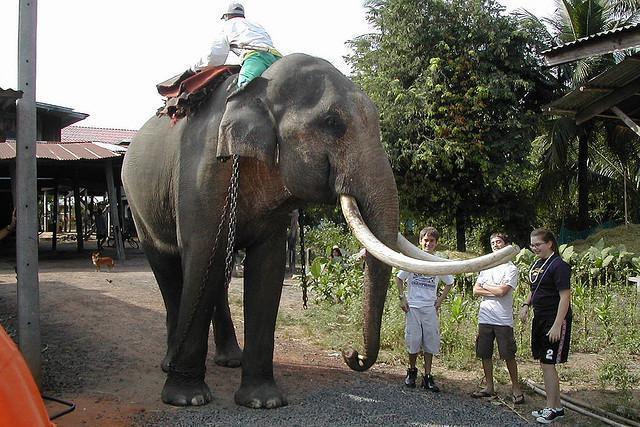How many humans are the picture?
Give a very brief answer. 4. How many people are in the photo?
Give a very brief answer. 5. How many cows are visible?
Give a very brief answer. 0. 